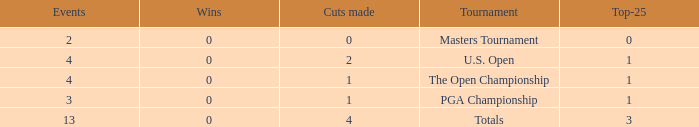How many cuts did he make in the tournament with 3 top 25s and under 13 events? None. 